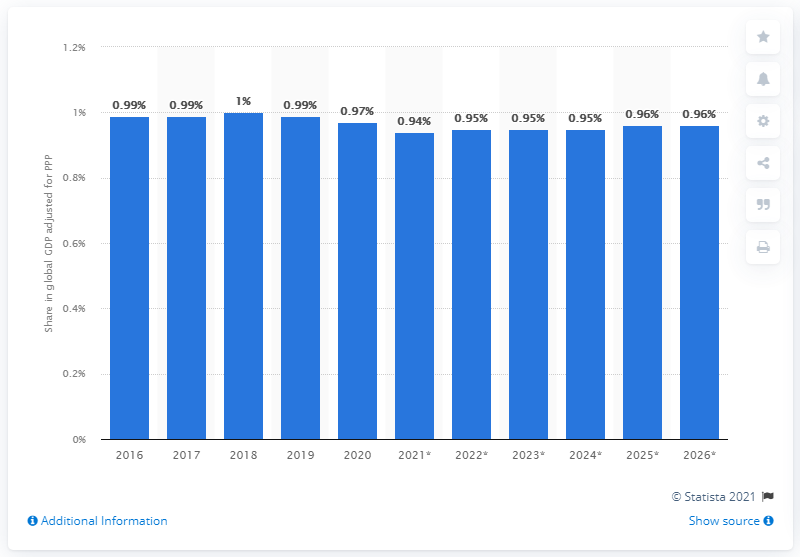Give some essential details in this illustration. In 2020, Thailand's share of the global gross domestic product, adjusted for purchasing power parity, was 0.97. 